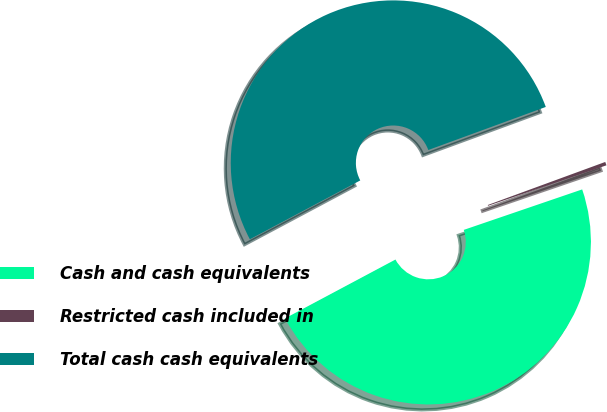Convert chart. <chart><loc_0><loc_0><loc_500><loc_500><pie_chart><fcel>Cash and cash equivalents<fcel>Restricted cash included in<fcel>Total cash cash equivalents<nl><fcel>47.45%<fcel>0.35%<fcel>52.2%<nl></chart> 